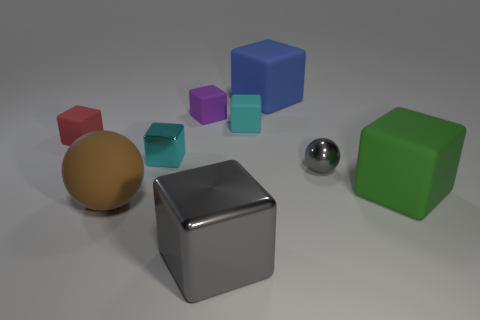There is a tiny ball that is the same color as the large metallic thing; what material is it?
Your answer should be compact. Metal. What number of things are either large spheres in front of the large blue rubber thing or large red balls?
Offer a terse response. 1. Are any large purple rubber things visible?
Offer a very short reply. No. What shape is the thing that is in front of the small red matte thing and behind the metal ball?
Your answer should be compact. Cube. There is a gray thing that is left of the small gray metallic sphere; how big is it?
Your response must be concise. Large. Is the color of the metallic object in front of the small metallic ball the same as the tiny shiny sphere?
Provide a succinct answer. Yes. What number of small blue matte objects are the same shape as the tiny cyan metallic object?
Ensure brevity in your answer.  0. What number of things are things on the left side of the tiny shiny block or big objects to the right of the large gray metal object?
Provide a short and direct response. 4. What number of purple objects are metallic balls or small matte spheres?
Provide a short and direct response. 0. There is a large cube that is both to the left of the big green matte cube and in front of the large blue matte cube; what is its material?
Offer a very short reply. Metal. 